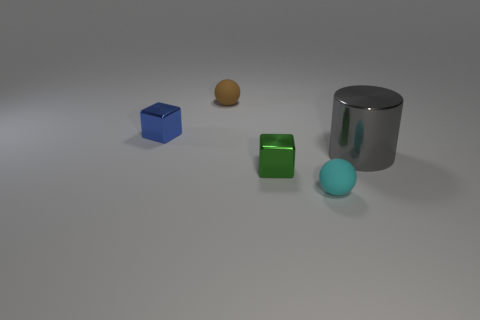Add 2 brown metallic cylinders. How many objects exist? 7 Subtract 1 cubes. How many cubes are left? 1 Subtract all spheres. How many objects are left? 3 Subtract all yellow cubes. Subtract all rubber spheres. How many objects are left? 3 Add 5 gray things. How many gray things are left? 6 Add 2 big metallic blocks. How many big metallic blocks exist? 2 Subtract all green cubes. How many cubes are left? 1 Subtract 1 brown balls. How many objects are left? 4 Subtract all yellow balls. Subtract all cyan cylinders. How many balls are left? 2 Subtract all yellow cylinders. How many green blocks are left? 1 